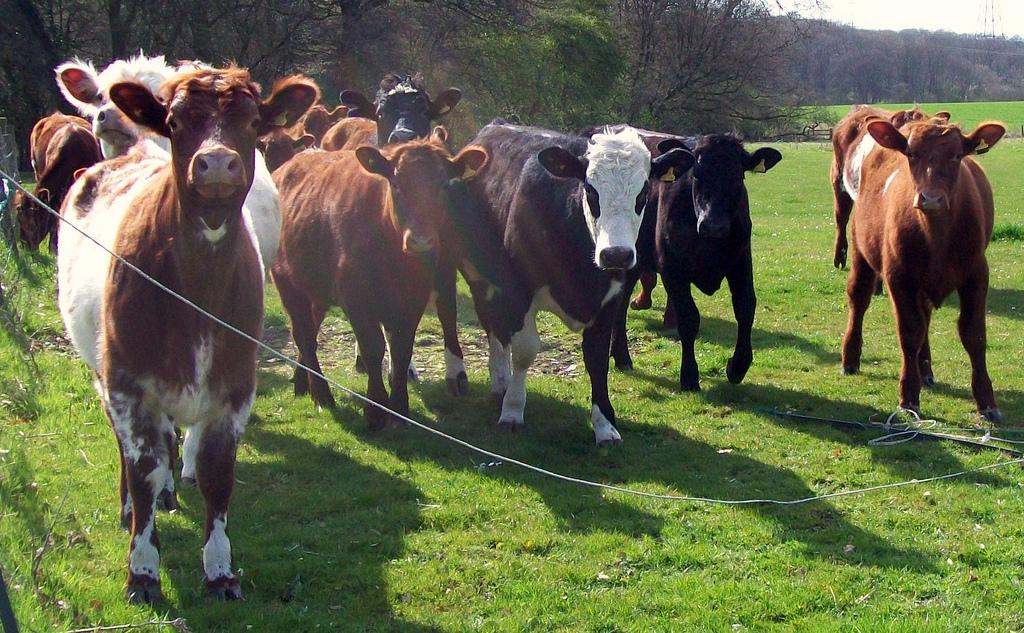Question: when were they standing there?
Choices:
A. At night.
B. Early morning.
C. During the day.
D. At sundown.
Answer with the letter. Answer: C Question: what colors are the cows?
Choices:
A. Brown, black and white.
B. Pink.
C. Green.
D. Yellow.
Answer with the letter. Answer: A Question: what animals are they?
Choices:
A. Goats.
B. Horses.
C. Cows.
D. Sheep.
Answer with the letter. Answer: C Question: what is fencing off the cows?
Choices:
A. A wooden fence.
B. A piece of thin rope.
C. An electric fence.
D. A gate.
Answer with the letter. Answer: B Question: where are all the cows facing?
Choices:
A. At the camera.
B. Toward the barn.
C. Toward the field.
D. Downhill.
Answer with the letter. Answer: A Question: what is hanging across the space between the camera and the cows?
Choices:
A. A wire or light chain.
B. An electrical wire.
C. A telephone wire.
D. A clothesline.
Answer with the letter. Answer: A Question: what surrounds the field?
Choices:
A. Bushes.
B. Verdant trees.
C. A fence.
D. Flowers.
Answer with the letter. Answer: B Question: what is in the background?
Choices:
A. A pond.
B. A barn.
C. A tractor.
D. Many trees.
Answer with the letter. Answer: D Question: what are the cows standing on?
Choices:
A. A field.
B. Grass.
C. Dirt.
D. Mud.
Answer with the letter. Answer: B Question: what is in the large field?
Choices:
A. Sheep.
B. Deer.
C. Horses.
D. Cows.
Answer with the letter. Answer: D Question: what is present in the background?
Choices:
A. Trees.
B. Forest.
C. Grass.
D. Vegetation.
Answer with the letter. Answer: A Question: how is the grass?
Choices:
A. Tall.
B. Thick.
C. Very lushy.
D. Very course.
Answer with the letter. Answer: C Question: what scene is it?
Choices:
A. A waterfall scene.
B. A forest scene.
C. An outdoor scene.
D. A mountain scene.
Answer with the letter. Answer: C Question: what is looking at the camera?
Choices:
A. One cow.
B. The calf.
C. Many cows.
D. Nothing is looking at the camera.
Answer with the letter. Answer: A 